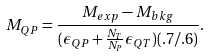<formula> <loc_0><loc_0><loc_500><loc_500>M _ { Q P } = \frac { M _ { e x p } - M _ { b k g } } { ( \epsilon _ { Q P } + \frac { N _ { T } } { N _ { P } } \epsilon _ { Q T } ) ( . 7 / . 6 ) } .</formula> 